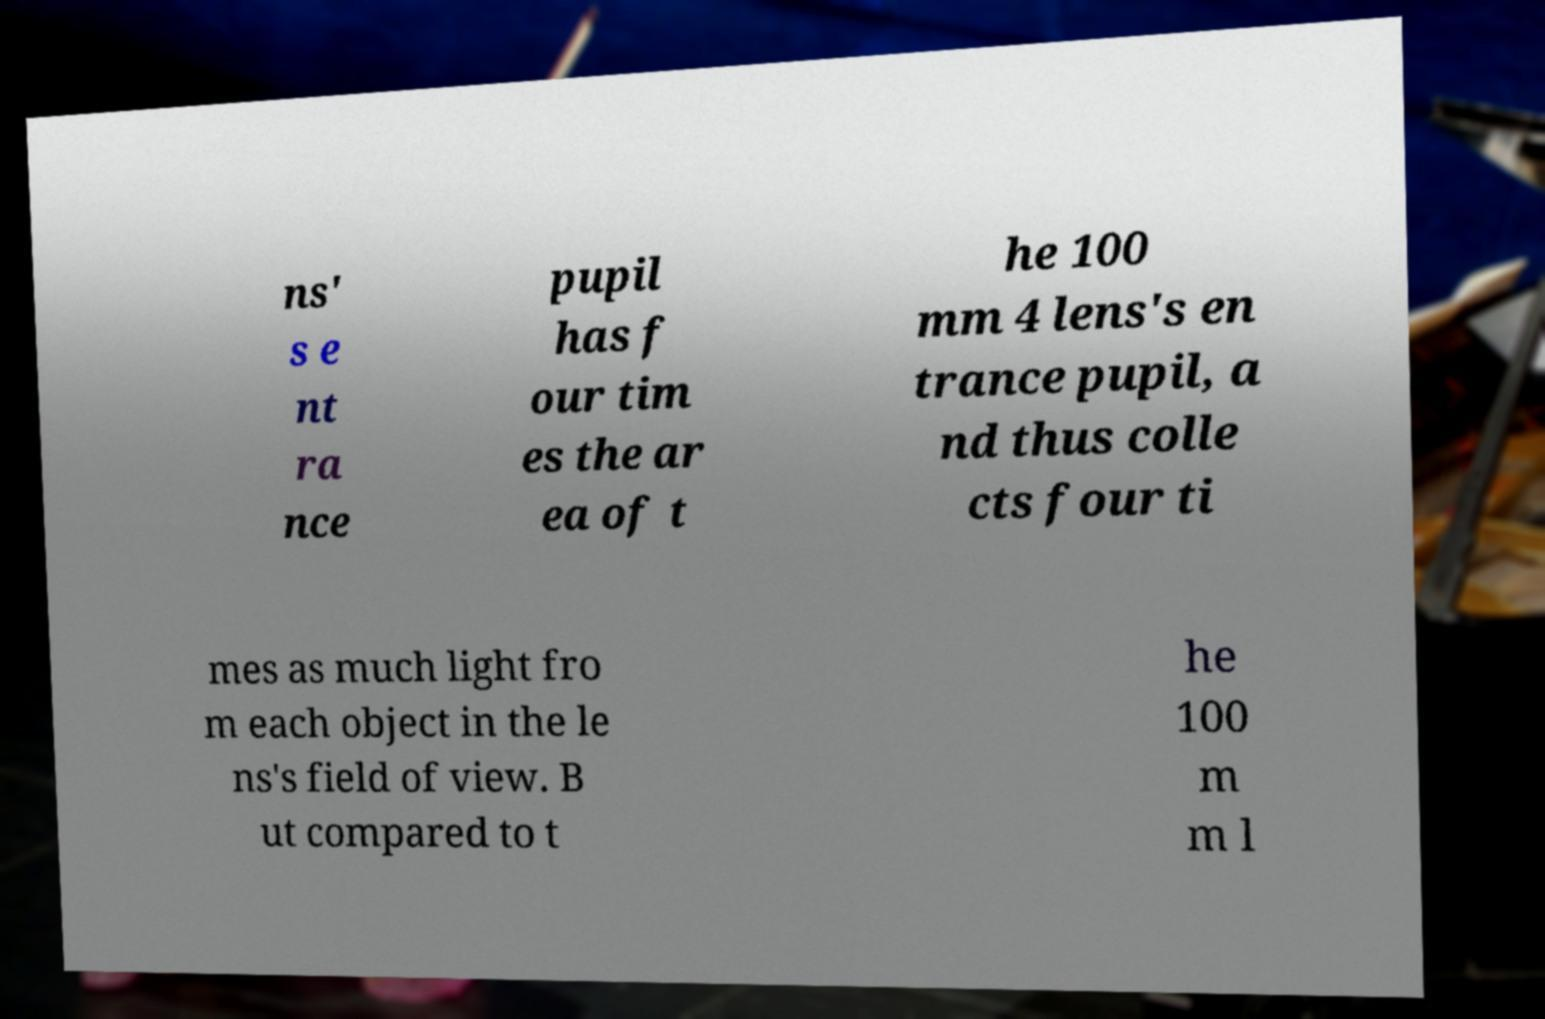Can you accurately transcribe the text from the provided image for me? ns' s e nt ra nce pupil has f our tim es the ar ea of t he 100 mm 4 lens's en trance pupil, a nd thus colle cts four ti mes as much light fro m each object in the le ns's field of view. B ut compared to t he 100 m m l 